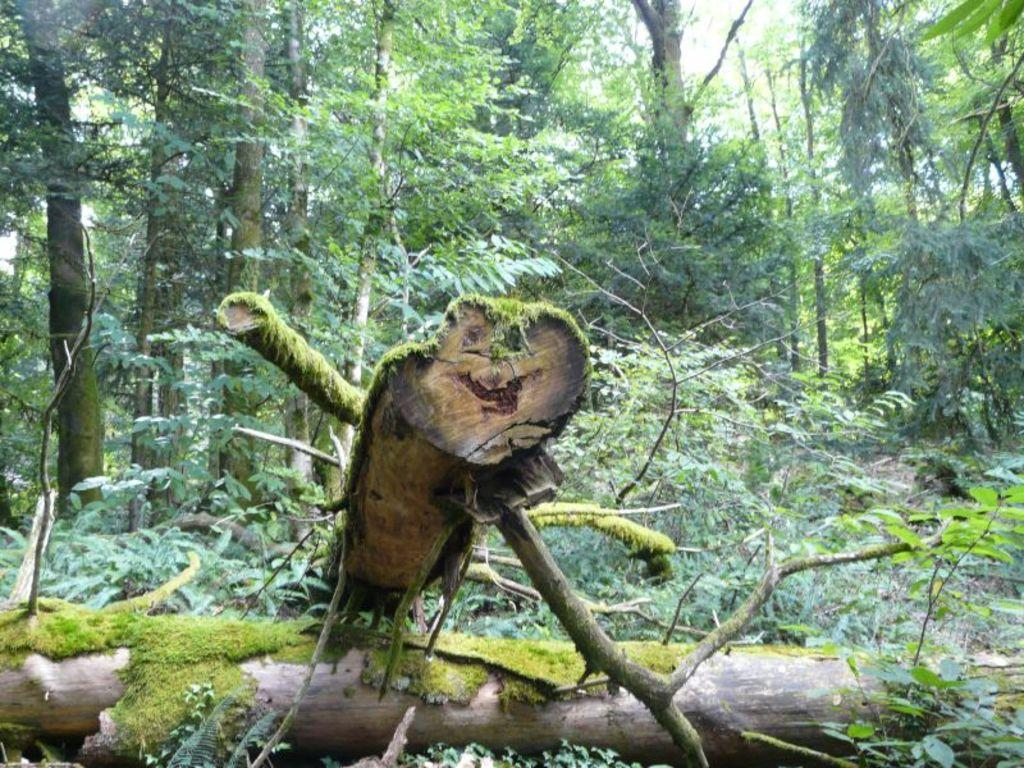What is the primary feature of the landscape in the image? There are many trees in the image. Can you describe any specific details about the trees? There is a broken stem on the land in the image. How does the crowd affect the movement of the truck in the image? There is no crowd or truck present in the image; it only features trees and a broken stem. 